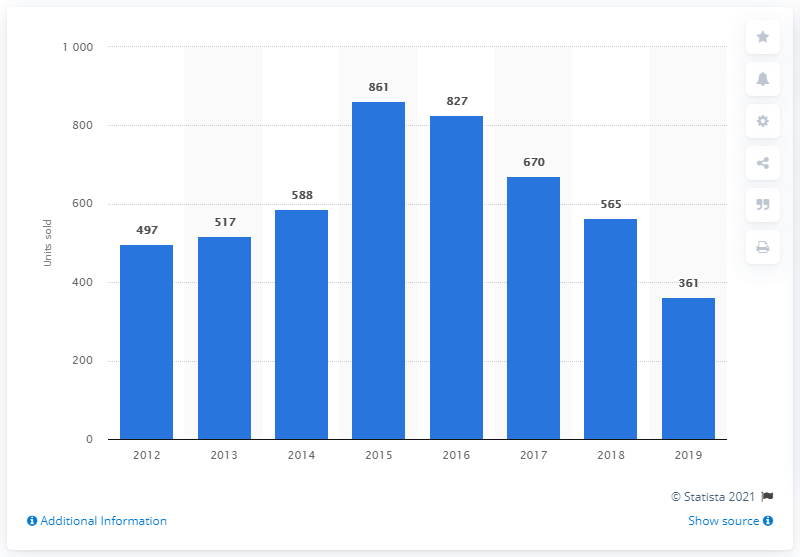List a handful of essential elements in this visual. In 2015, a total of 861 Porsche cars were sold in Turkey. 